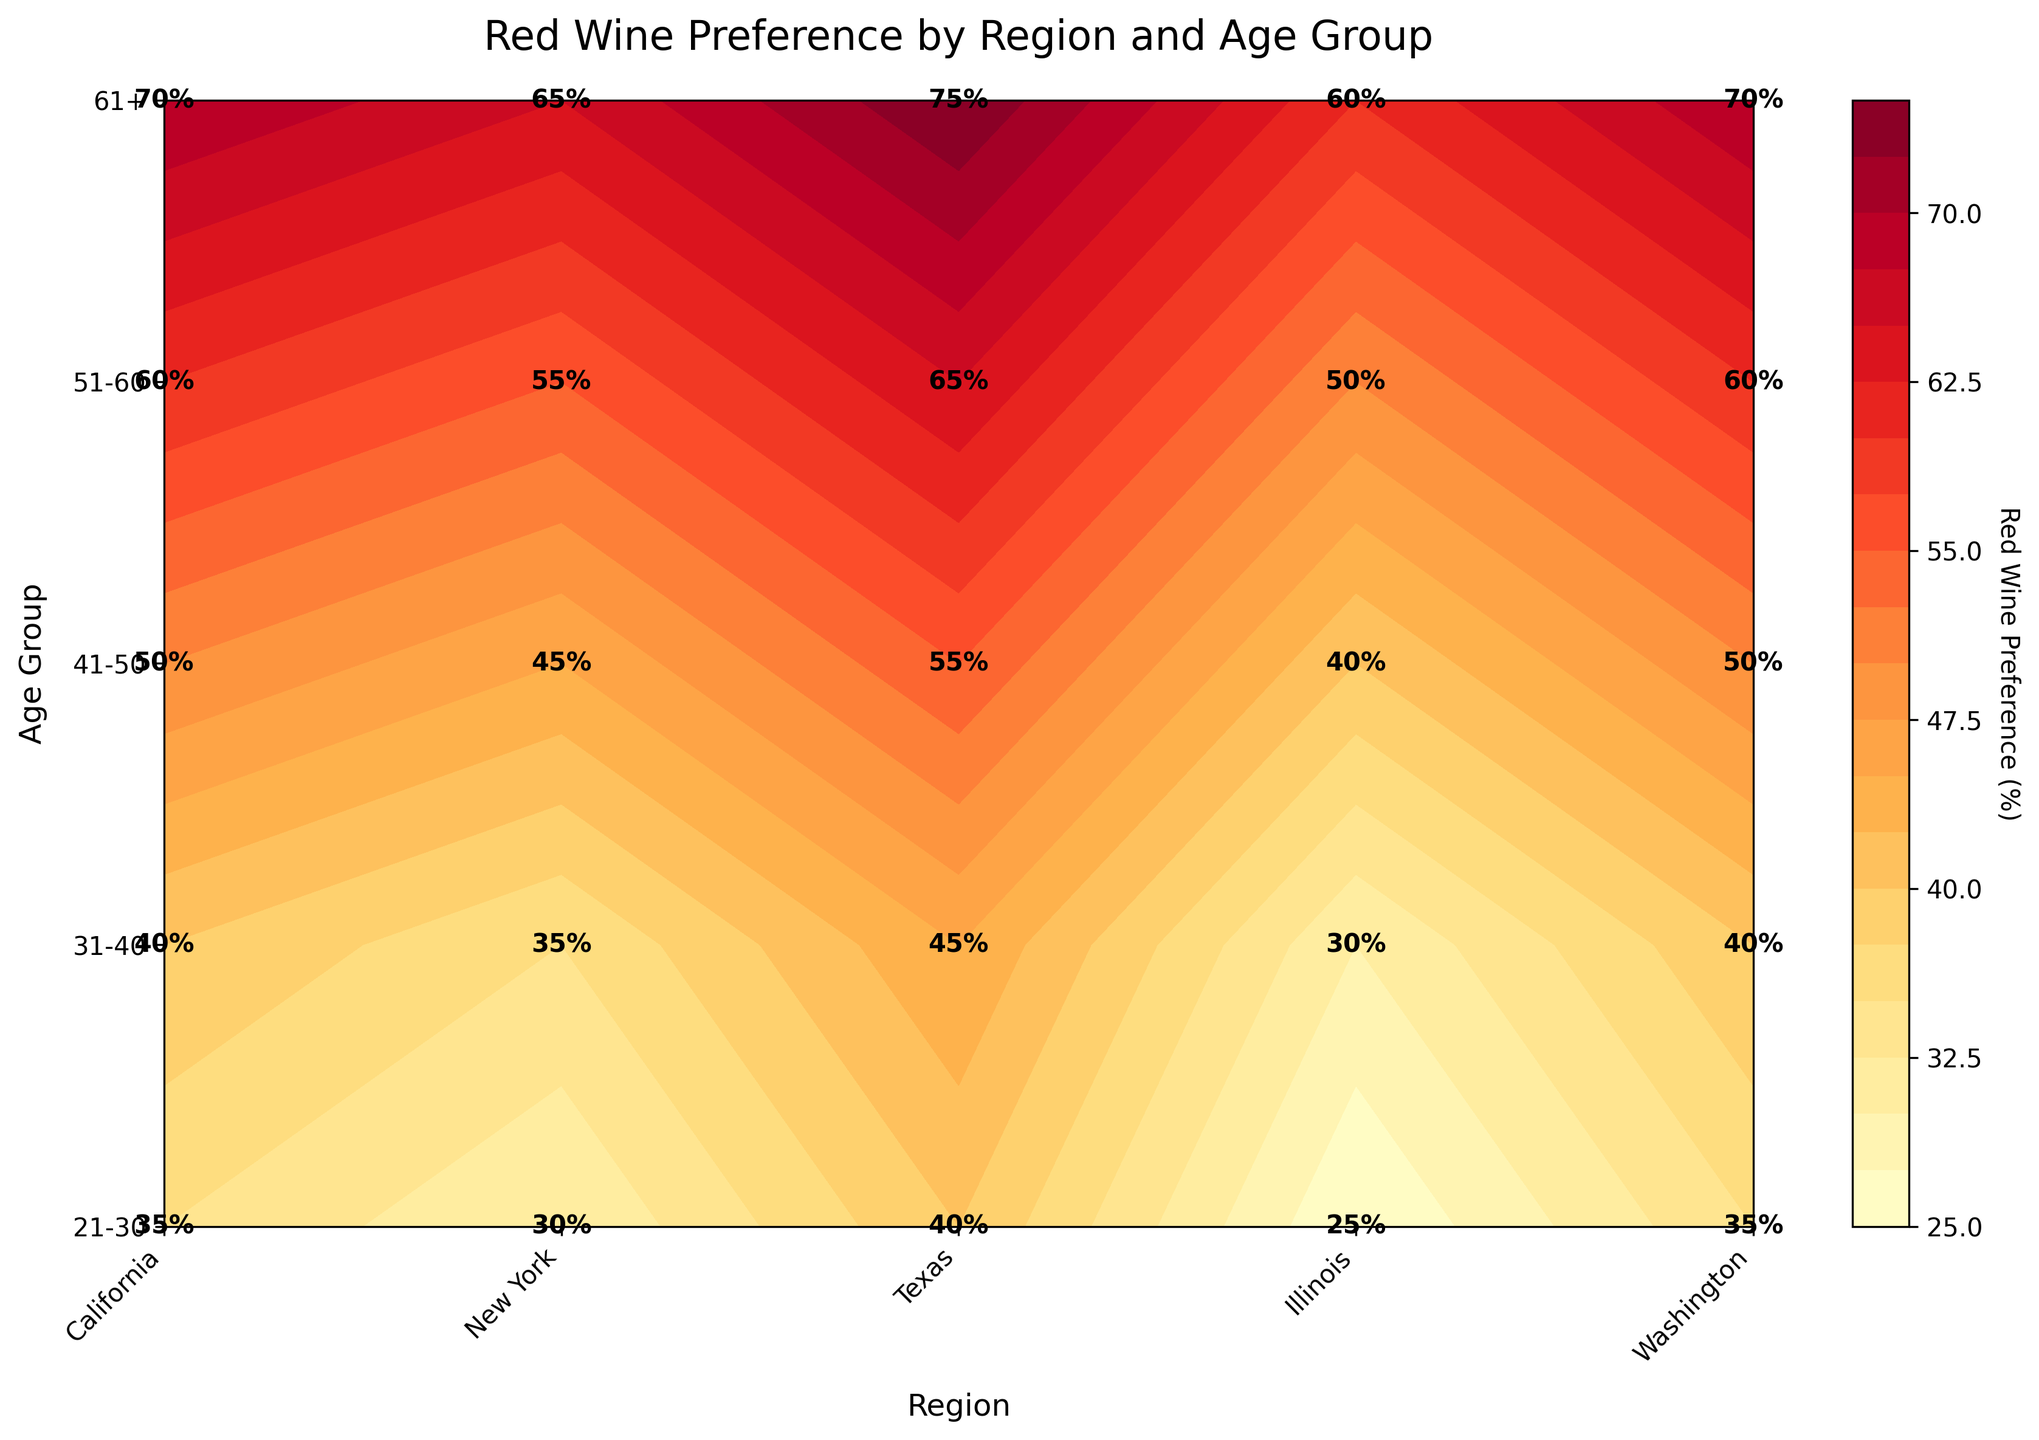what is the title of the figure? The title is located at the top of the figure and is directly readable. It gives an overview of what the figure is about.
Answer: Red Wine Preference by Region and Age Group What is the red wine preference percentage for the 61+ age group in Texas? Locate Texas along the x-axis and 61+ along the y-axis, then find their intersection point. The value at this intersection denotes the red wine preference.
Answer: 75% Which region has the highest red wine preference for the 51-60 age group? Locate the 51-60 age group along the y-axis, then find the highest value at the intersection points with the regions on the x-axis.
Answer: Texas How does the red wine preference for the 31-40 age group in New York compare to that in California? Compare the values at the intersection of the 31-40 age group and the regions New York and California on the x-axis.
Answer: New York: 35%, California: 40% What is the average red wine preference percentage for the 41-50 age group across all regions? Locate the 41-50 age group row, sum up the red wine preferences across all regions, and then divide by the number of regions. (50+45+55+40+50)/5 = 48
Answer: 48% Which region shows a declining trend in red wine preference with increasing age? Check each region's column to see the trend of red wine preference values from the 21-30 age group to the 61+ age group.
Answer: None Is there a region where the 21-30 age group has a higher red wine preference percentage compared to the 31-40 age group? Compare the values for the 21-30 and 31-40 age groups for each region.
Answer: Texas What region has the lowest red wine preference for the 21-30 age group? Locate the 21-30 age group along the y-axis, then find the lowest value among regions on the x-axis.
Answer: Illinois How does the red wine preference for the 61+ age group in Illinois compare to Washington? Compare the values at the intersection of the 61+ age group with Illinois and Washington on the x-axis.
Answer: Illinois: 60%, Washington: 70% What's the median red wine preference for the 31-40 age group across all regions? Locate the 31-40 age group row, list the red wine preferences, and find the middle value after sorting them. Sorted: [30, 35, 40, 40, 45]; Median: 40
Answer: 40% 